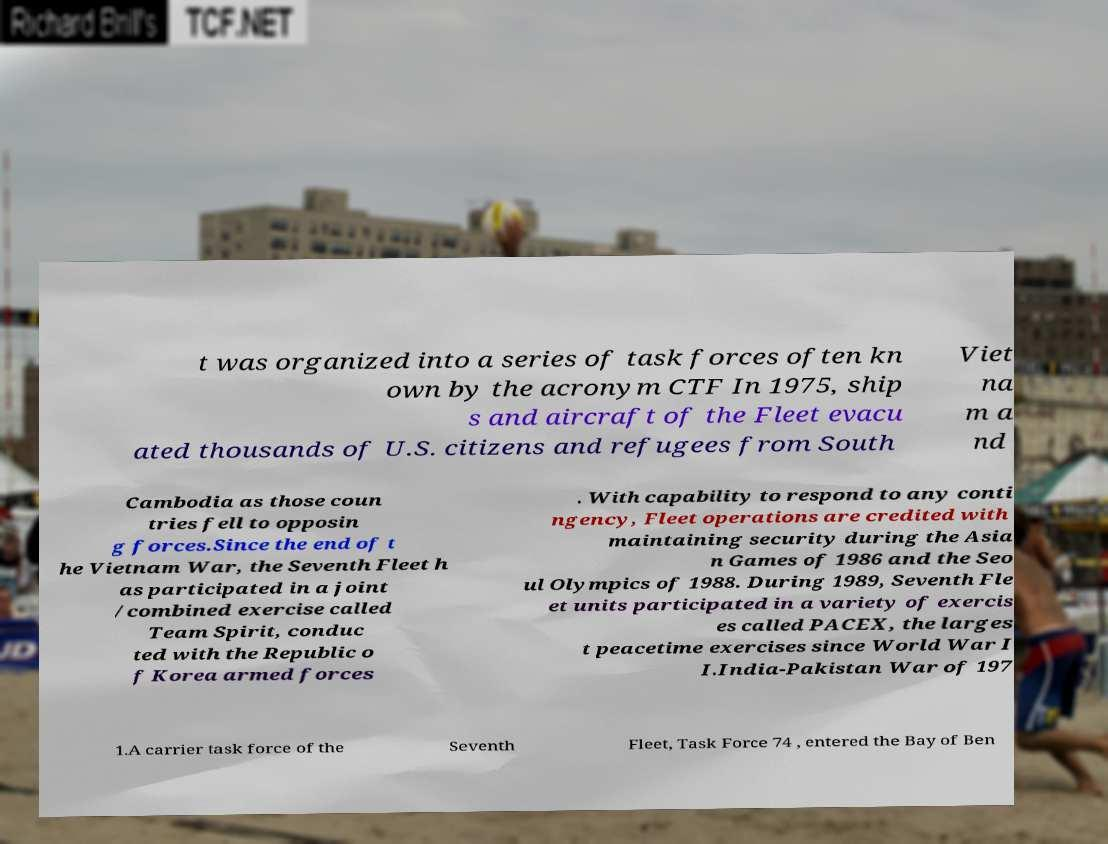I need the written content from this picture converted into text. Can you do that? t was organized into a series of task forces often kn own by the acronym CTF In 1975, ship s and aircraft of the Fleet evacu ated thousands of U.S. citizens and refugees from South Viet na m a nd Cambodia as those coun tries fell to opposin g forces.Since the end of t he Vietnam War, the Seventh Fleet h as participated in a joint /combined exercise called Team Spirit, conduc ted with the Republic o f Korea armed forces . With capability to respond to any conti ngency, Fleet operations are credited with maintaining security during the Asia n Games of 1986 and the Seo ul Olympics of 1988. During 1989, Seventh Fle et units participated in a variety of exercis es called PACEX, the larges t peacetime exercises since World War I I.India-Pakistan War of 197 1.A carrier task force of the Seventh Fleet, Task Force 74 , entered the Bay of Ben 